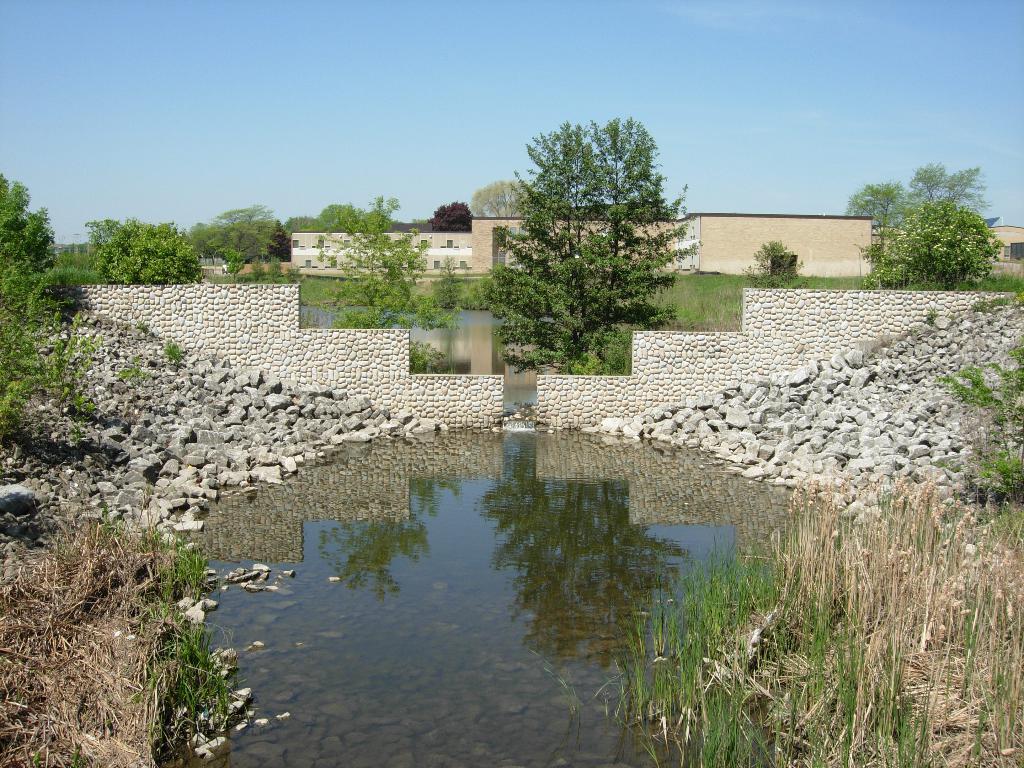Please provide a concise description of this image. Here we can see water, rocks, grass and plants. Background there are buildings and trees. Sky is in blue color. 